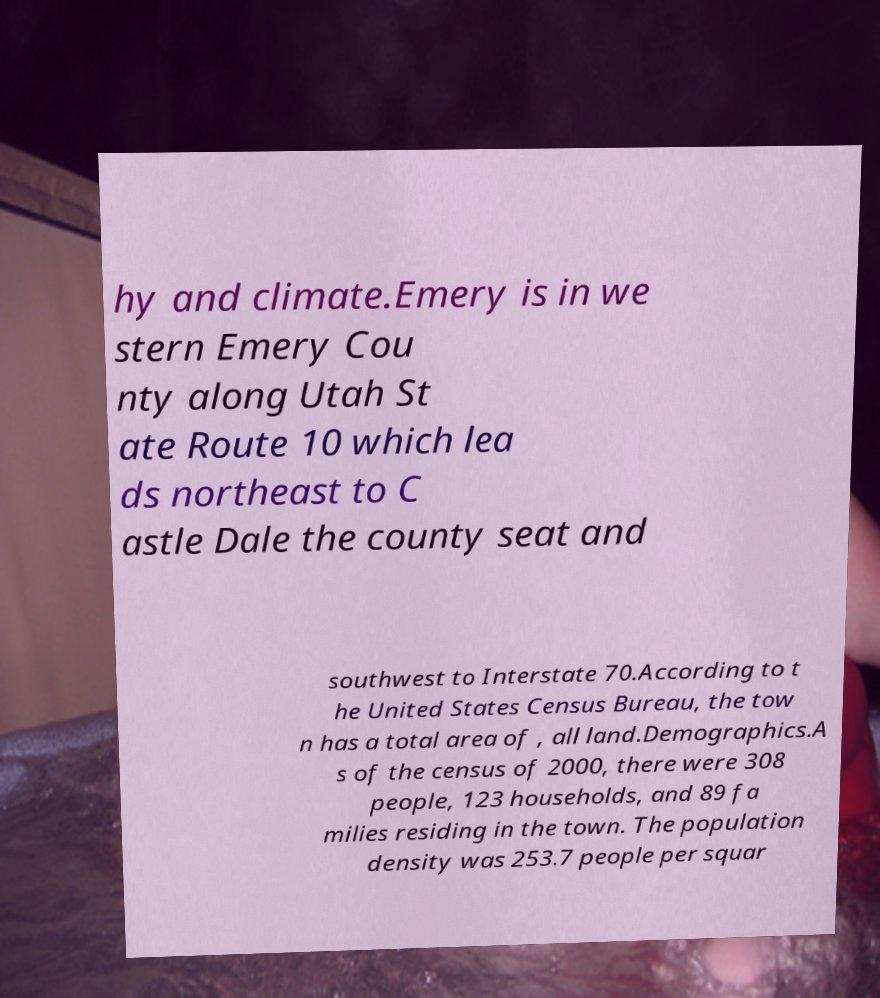Can you read and provide the text displayed in the image?This photo seems to have some interesting text. Can you extract and type it out for me? hy and climate.Emery is in we stern Emery Cou nty along Utah St ate Route 10 which lea ds northeast to C astle Dale the county seat and southwest to Interstate 70.According to t he United States Census Bureau, the tow n has a total area of , all land.Demographics.A s of the census of 2000, there were 308 people, 123 households, and 89 fa milies residing in the town. The population density was 253.7 people per squar 